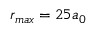Convert formula to latex. <formula><loc_0><loc_0><loc_500><loc_500>r _ { \max } = 2 5 a _ { 0 }</formula> 